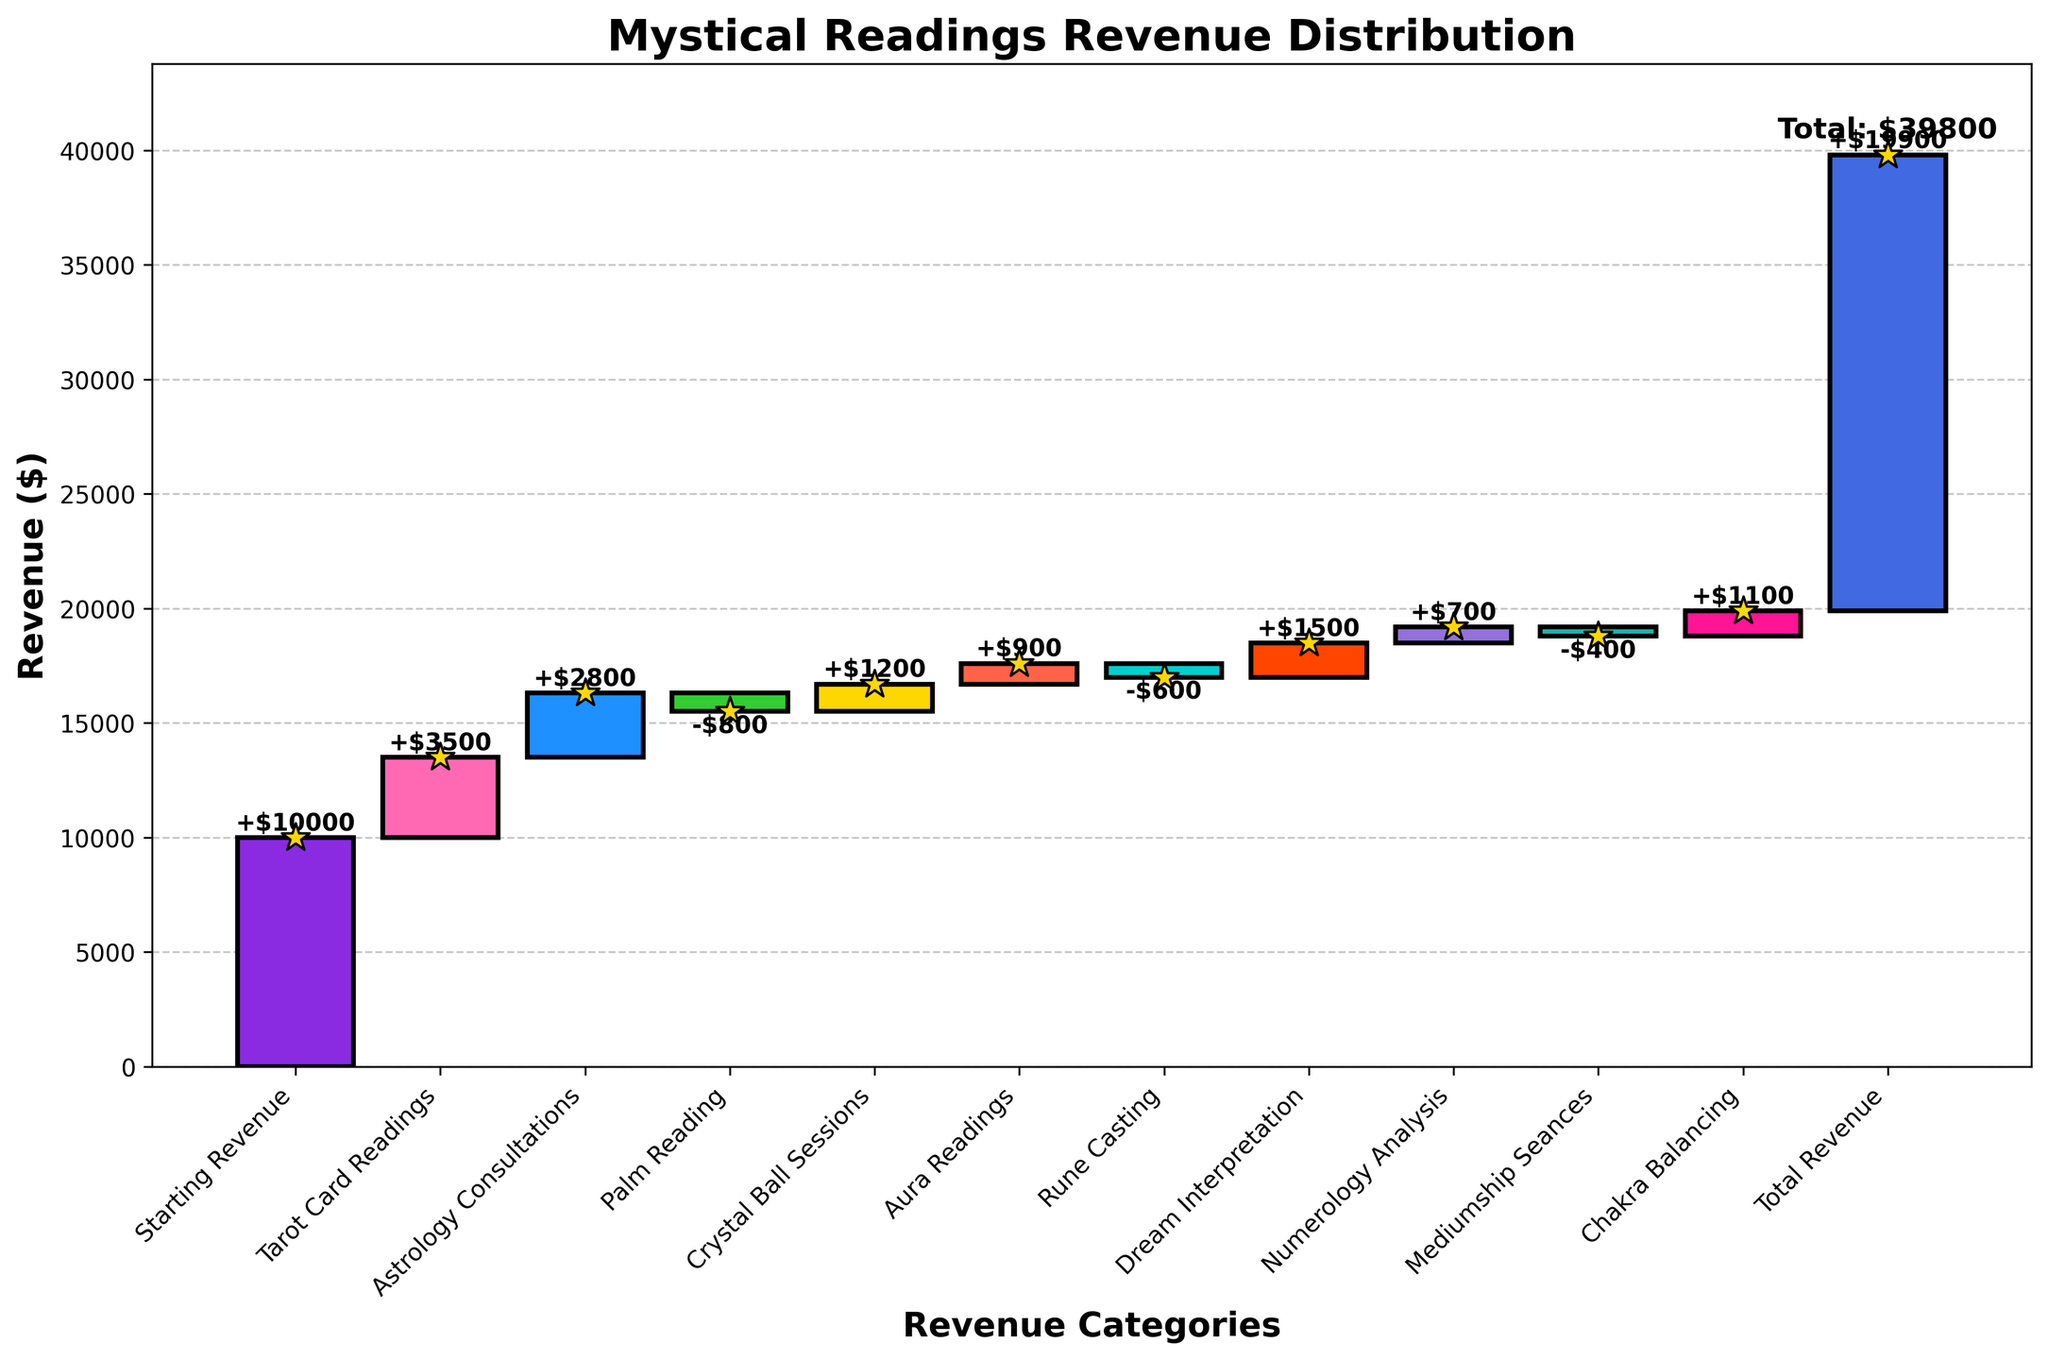What is the title of the chart? The title of the chart is prominently placed at the top and contains key information about the overall subject of the data.
Answer: Mystical Readings Revenue Distribution Which reading category contributed the most revenue? By observing the bars in the graph, the category with the tallest positive bar indicates the highest revenue contribution.
Answer: Tarot Card Readings Which category had the highest negative impact on the revenue? The bars descending from the previous level indicate a negative impact, the category with the longest descending bar had the highest negative impact.
Answer: Palm Reading What is the total revenue? The last point or bar on the chart represents the cumulative sum of all values, which is labeled accordingly.
Answer: $19900 How much revenue did Numerology Analysis contribute? Find the bar corresponding to Numerology Analysis and read the numeric value associated with its height.
Answer: $700 How many categories had a positive impact on revenue? Count all the bars that ascend from the previous level in the figure.
Answer: 8 What is the combined revenue from Astrology Consultations and Dream Interpretation? Sum the individual contributions of these two categories as indicated on the chart: $2800 + $1500.
Answer: $4300 How does the revenue change from Starting Revenue to Total Revenue? Observe the flow from the initial value to the final value, calculating the difference between the Starting Revenue ($10000) and Total Revenue ($19900).
Answer: +$9900 What is the net impact of all the negative contributions? Add the absolute values of all negative contributions: $800 + $600 + $400.
Answer: $1800 Which had a smaller impact on revenue, Crystal Ball Sessions or Aura Readings? Compare the numeric values of both categories as represented by the height of their bars.
Answer: Aura Readings 